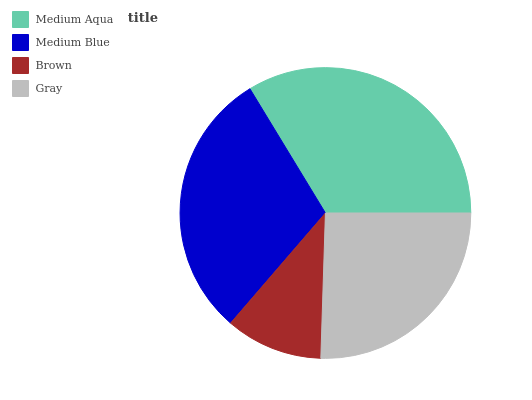Is Brown the minimum?
Answer yes or no. Yes. Is Medium Aqua the maximum?
Answer yes or no. Yes. Is Medium Blue the minimum?
Answer yes or no. No. Is Medium Blue the maximum?
Answer yes or no. No. Is Medium Aqua greater than Medium Blue?
Answer yes or no. Yes. Is Medium Blue less than Medium Aqua?
Answer yes or no. Yes. Is Medium Blue greater than Medium Aqua?
Answer yes or no. No. Is Medium Aqua less than Medium Blue?
Answer yes or no. No. Is Medium Blue the high median?
Answer yes or no. Yes. Is Gray the low median?
Answer yes or no. Yes. Is Medium Aqua the high median?
Answer yes or no. No. Is Medium Aqua the low median?
Answer yes or no. No. 